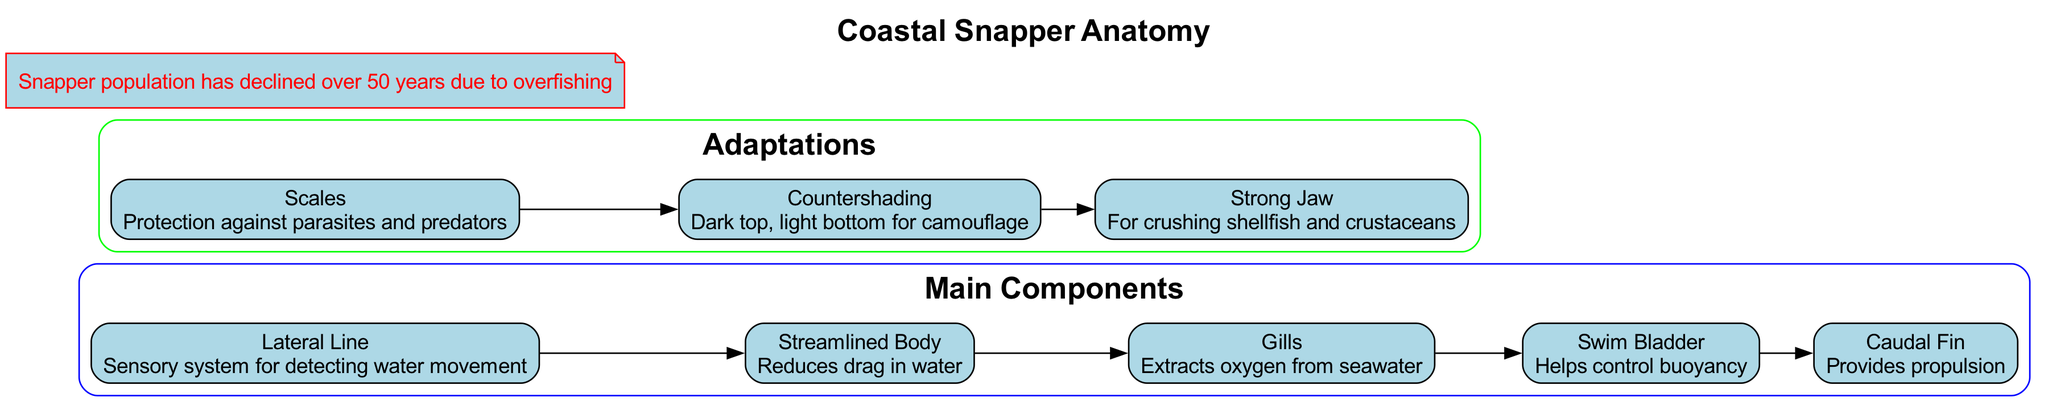What is the title of the diagram? The title of the diagram is explicitly stated at the top as "Coastal Snapper Anatomy".
Answer: Coastal Snapper Anatomy How many main components are listed? There are five main components listed in the section labeled "Main Components".
Answer: 5 What is the purpose of the Swim Bladder? The Swim Bladder's function is described as "Helps control buoyancy" in the diagram.
Answer: Helps control buoyancy Which adaptation provides camouflage for the Coastal Snapper? The adaptation described as "Countershading" provides camouflage, with a dark top and light bottom.
Answer: Countershading What do Scales protect against? The diagram specifically states that "Protection against parasites and predators" is the function of Scales.
Answer: Parasites and predators How do the adaptations contribute to the fish's survival? The adaptations of "Scales," "Countershading," and "Strong Jaw" work together to provide protection, concealment, and feeding capabilities, which enhances survival against threats in its environment.
Answer: Protection, concealment, and feeding What is the relationship between the Lateral Line and the Streamlined Body? The Lateral Line is connected to the Streamlined Body, indicating that the sensory system for detecting water movement is essential for the fish's hydrodynamic shape.
Answer: Lateral Line → Streamlined Body How has the snapper population changed over the years? The historical note indicates that the snapper population has declined over the past 50 years, specifically citing overfishing as the cause.
Answer: Declined over 50 years due to overfishing What feature aids in propulsion? The diagram specifies that the "Caudal Fin" provides propulsion for the Coastal Snapper as part of its anatomical structure.
Answer: Caudal Fin 